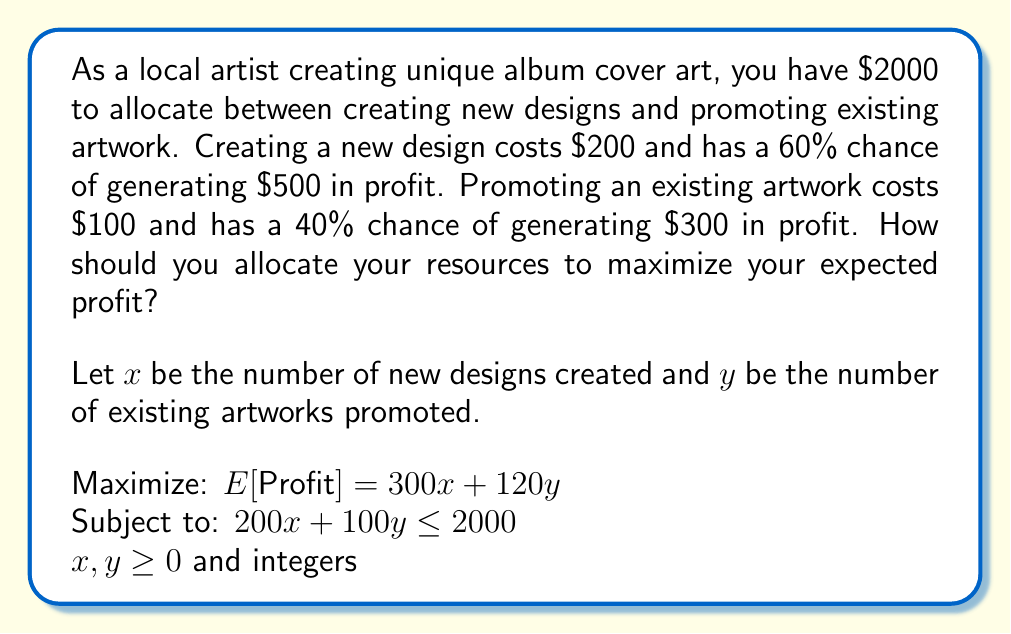Give your solution to this math problem. To solve this problem, we'll use the following approach:

1. Set up the linear programming problem:
   Maximize: $E[Profit] = 300x + 120y$
   Subject to: $200x + 100y \leq 2000$
   $x, y \geq 0$ and integers

2. Plot the constraint line:
   $200x + 100y = 2000$
   When $x = 0$, $y = 20$
   When $y = 0$, $x = 10$

3. Find the corner points:
   (0, 20), (10, 0), and the intersection of $200x + 100y = 2000$ with $y = 0$ and $x = 0$

4. Calculate the expected profit at each corner point:
   (0, 20): $E[Profit] = 300(0) + 120(20) = 2400$
   (10, 0): $E[Profit] = 300(10) + 120(0) = 3000$
   (8, 8): $E[Profit] = 300(8) + 120(8) = 3360$

5. The optimal solution is at the point (8, 8), which gives the maximum expected profit.

[asy]
size(200);
draw((0,0)--(10,0)--(10,20)--(0,20)--cycle);
draw((0,20)--(10,0),red);
dot((0,20));
dot((10,0));
dot((8,8));
label("(0,20)",(0,20),W);
label("(10,0)",(10,0),S);
label("(8,8)",(8,8),NE);
label("$200x + 100y = 2000$",(5,10),E,red);
label("$x$",(10,0),SE);
label("$y$",(0,20),NW);
[/asy]

Therefore, to maximize expected profit, you should create 8 new designs and promote 8 existing artworks.
Answer: Create 8 new designs and promote 8 existing artworks for a maximum expected profit of $3360. 